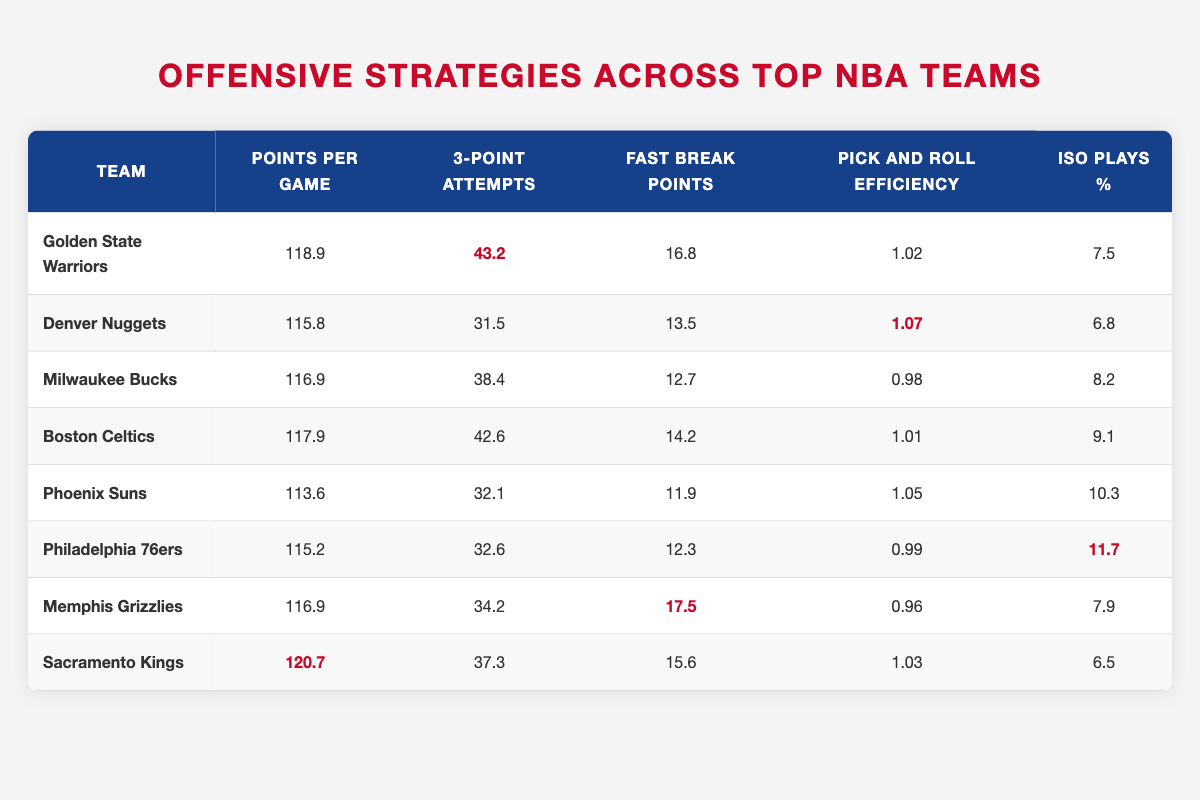What team has the highest points per game? The team with the highest points per game can be found by looking for the largest value in the "Points per Game" column. The Warriors have 118.9 points, while the Kings have 120.7 points, which is the highest.
Answer: Sacramento Kings What is the average number of 3-point attempts across all teams? To find the average, sum all the values in the "3-Point Attempts" column: (43.2 + 31.5 + 38.4 + 42.6 + 32.1 + 32.6 + 34.2 + 37.3) =  338.9. There are 8 teams, so dividing by 8 gives us an average of 338.9 / 8 = 42.36.
Answer: 42.36 Did the Milwaukee Bucks have more fast break points than the Philadelphia 76ers? The fast break points for the Bucks is 12.7, while for the 76ers it is 12.3. Since 12.7 is greater than 12.3, this means the Bucks had more fast break points than the 76ers.
Answer: Yes Which team has the highest pick and roll efficiency? The highest pick and roll efficiency can be identified by inspecting the "Pick and Roll Efficiency" column for the highest value. The Denver Nuggets have 1.07, which is greater than the other teams' values.
Answer: Denver Nuggets What is the total number of 3-point attempts for the top three teams in points per game? First, identify the top three teams based on points per game: Sacramento Kings (37.3), Golden State Warriors (43.2), and Boston Celtics (42.6). Now, sum their 3-point attempts: 37.3 + 43.2 + 42.6 = 123.1.
Answer: 123.1 Is it true that all teams have more than 6% Iso plays? Looking across the "Iso Plays %" column, we see the values: 7.5, 6.8, 8.2, 9.1, 10.3, 11.7, 7.9, and 6.5. Since the Kings have 6.5%, which is less than or equal to 6%, the statement is false.
Answer: No 